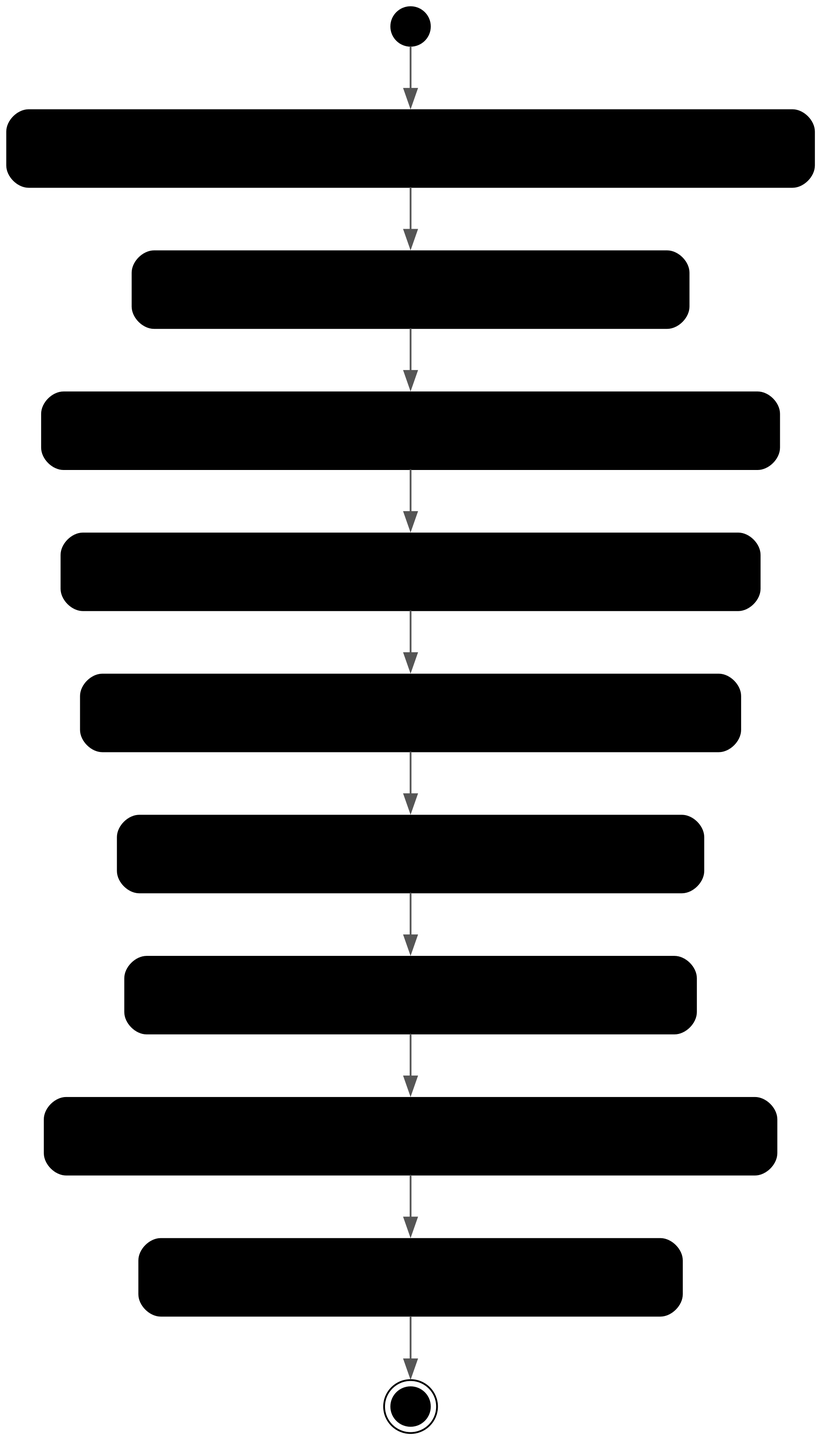What is the first activity in the diagram? The first activity listed in the diagram is "Collect Customer Feedback". It is the first element that follows the initial node, indicating the start of the process.
Answer: Collect Customer Feedback How many activities are there in total? The diagram contains a total of 8 activities, which are all steps taken after the initial node and before reaching the final node, excluding the initial and final nodes themselves.
Answer: 8 Which activity comes before "Generate Report"? "Interpret Results" comes directly before "Generate Report" in the flow of the diagram, indicating that one must interpret the results before generating the report.
Answer: Interpret Results What is the end point of the activity diagram? The end point of the activity diagram is "End", which is represented as the final node concluding the process.
Answer: End What is the relationship between "Segment Data" and "Analyze Data"? "Segment Data" leads to "Analyze Data"; after the data is segmented based on demographics or purchase history, analysis follows to draw insights.
Answer: Segment Data leads to Analyze Data How many nodes represent activities in the diagram? There are 8 nodes that represent activities in the diagram; these include all the steps from data collection to report distribution.
Answer: 8 What must be done after generating the report? After generating the report, it must be reviewed for accuracy and completeness before finalizing it.
Answer: Review Report What activity directly follows "Preprocess Data"? "Segment Data" directly follows "Preprocess Data", meaning that data segmentation is the next step after data preprocessing.
Answer: Segment Data 